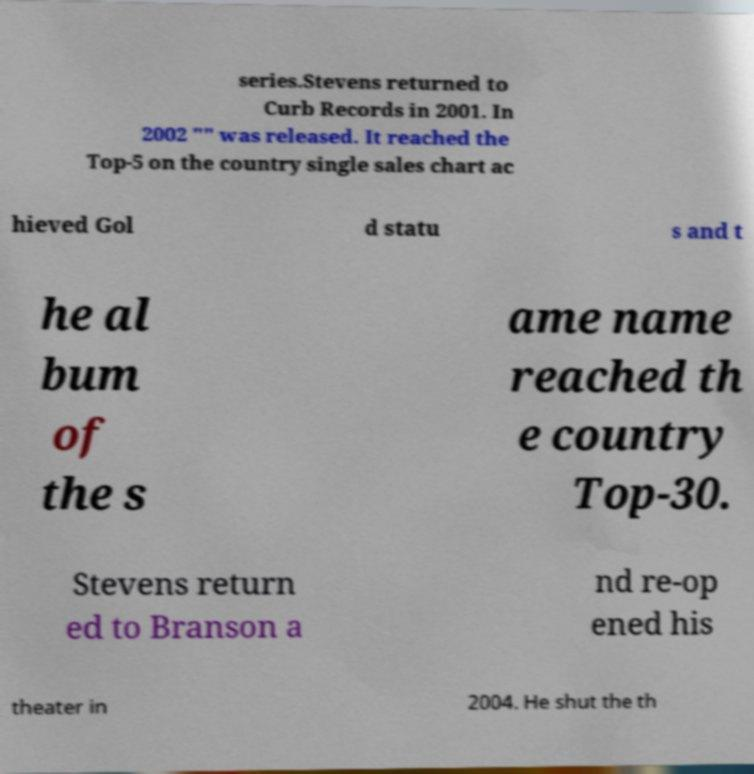Please read and relay the text visible in this image. What does it say? series.Stevens returned to Curb Records in 2001. In 2002 "" was released. It reached the Top-5 on the country single sales chart ac hieved Gol d statu s and t he al bum of the s ame name reached th e country Top-30. Stevens return ed to Branson a nd re-op ened his theater in 2004. He shut the th 